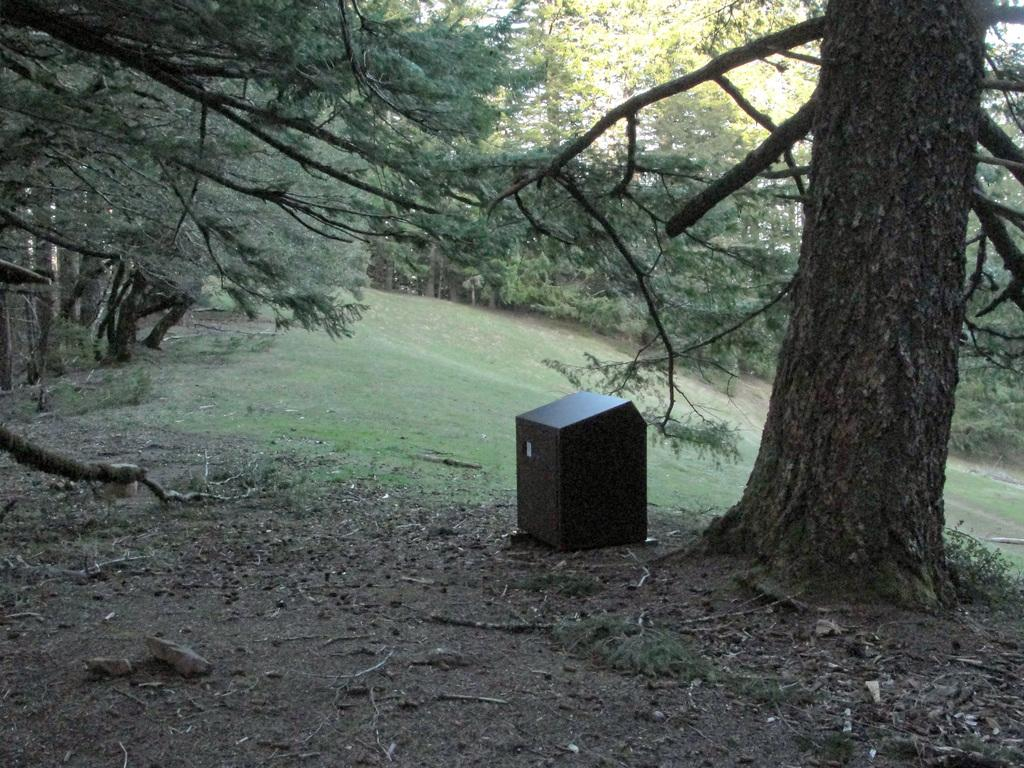What type of vegetation can be seen in the image? There are trees in the image. What object is on the ground in the image? There is a box on the ground in the image. Where is the box located in relation to the trees? The box is beside a tree. What can be seen on the left side of the image? There are stones on the left side of the image. What is the name of the friend who is holding the fruit in the image? There is no friend or fruit present in the image. What type of fruit is the friend eating in the image? There is no friend or fruit present in the image. 